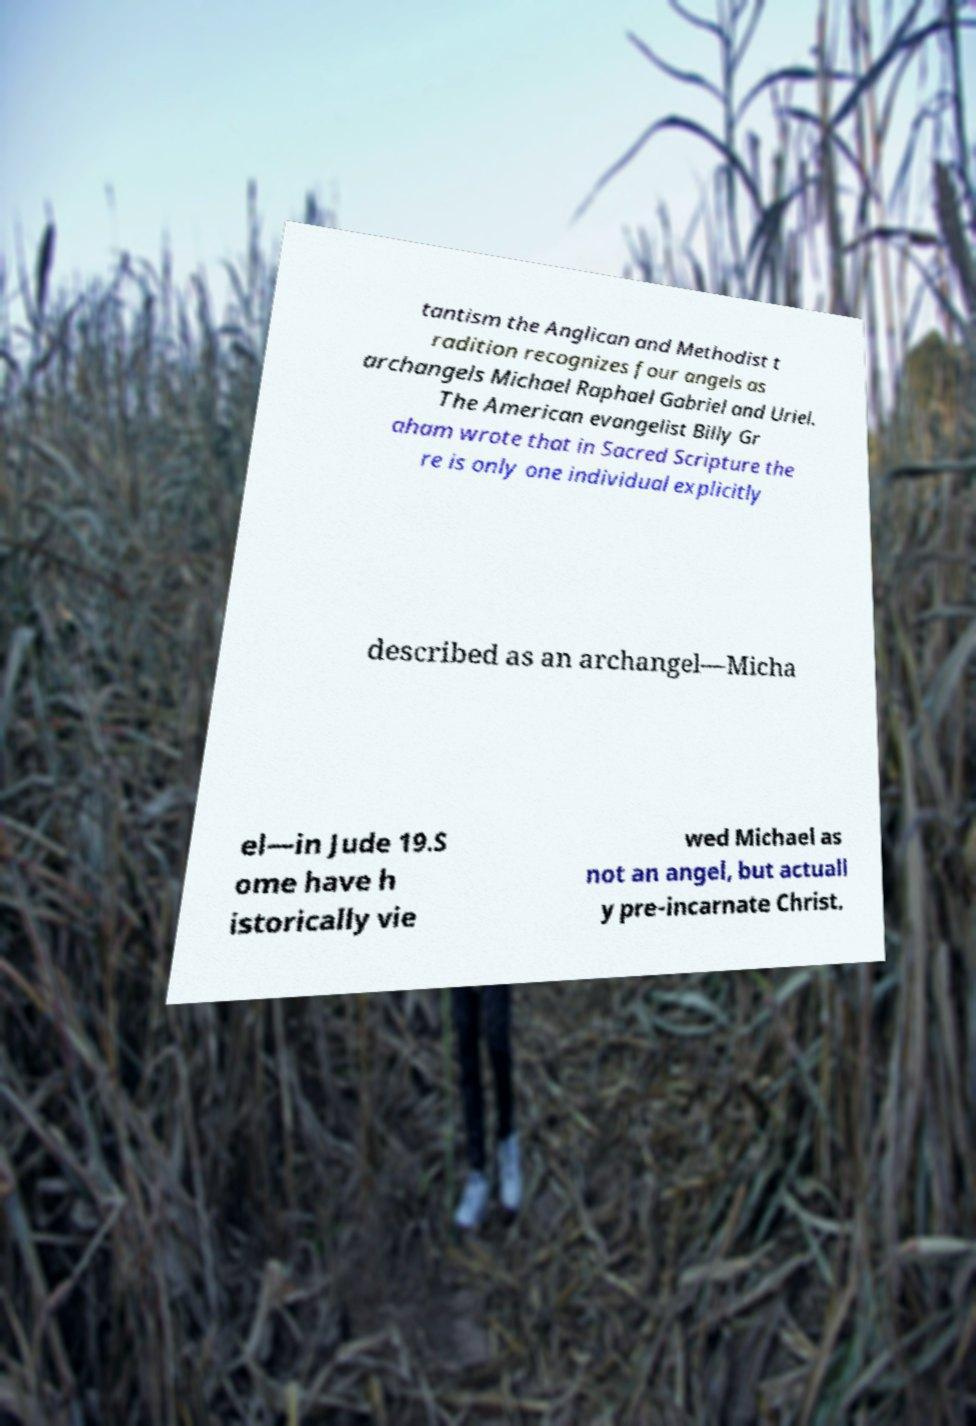There's text embedded in this image that I need extracted. Can you transcribe it verbatim? tantism the Anglican and Methodist t radition recognizes four angels as archangels Michael Raphael Gabriel and Uriel. The American evangelist Billy Gr aham wrote that in Sacred Scripture the re is only one individual explicitly described as an archangel—Micha el—in Jude 19.S ome have h istorically vie wed Michael as not an angel, but actuall y pre-incarnate Christ. 